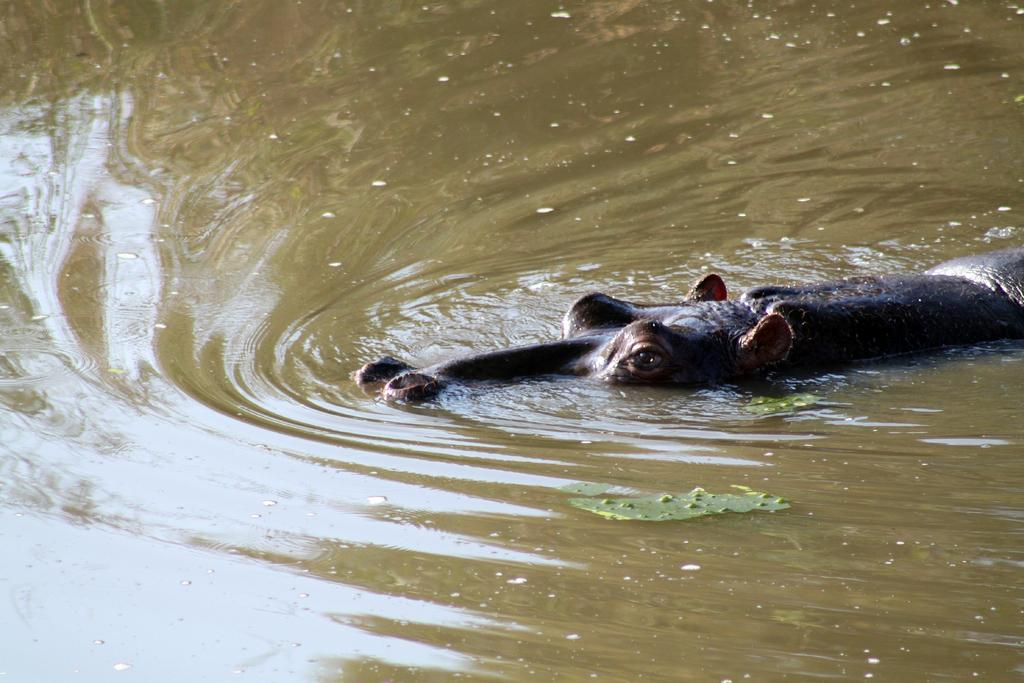What is in the water in the image? There is an animal in the water in the image. Can you describe the appearance of the animal? The animal is brown in color. What type of vegetation can be seen in the image? There are green leaves visible in the image. What type of sail can be seen on the house in the image? There is no house or sail present in the image; it features an animal in the water and green leaves. 